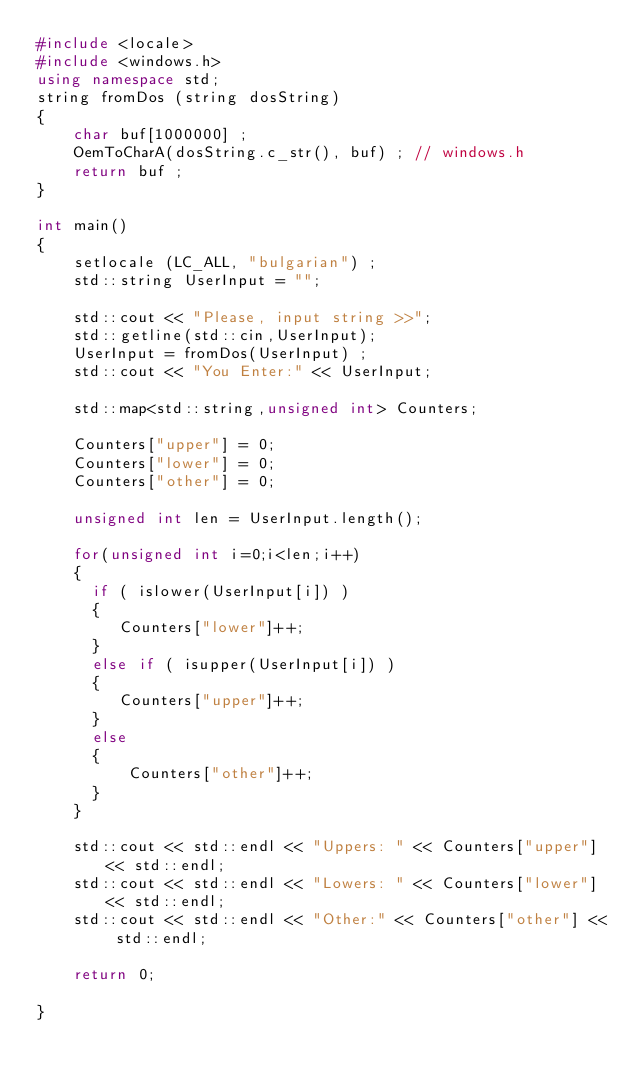<code> <loc_0><loc_0><loc_500><loc_500><_C++_>#include <locale>
#include <windows.h>
using namespace std;
string fromDos (string dosString)
{
	char buf[1000000] ;
	OemToCharA(dosString.c_str(), buf) ; // windows.h
	return buf ;
}

int main()
{
	setlocale (LC_ALL, "bulgarian") ;
    std::string UserInput = "";

    std::cout << "Please, input string >>";
    std::getline(std::cin,UserInput);
    UserInput = fromDos(UserInput) ;
    std::cout << "You Enter:" << UserInput;

    std::map<std::string,unsigned int> Counters;

    Counters["upper"] = 0;
    Counters["lower"] = 0;
    Counters["other"] = 0;

    unsigned int len = UserInput.length();

    for(unsigned int i=0;i<len;i++)
    {
      if ( islower(UserInput[i]) )
      {
         Counters["lower"]++;
      }
      else if ( isupper(UserInput[i]) )
      {
         Counters["upper"]++;
      }
      else
      {
          Counters["other"]++;
      }
    }

    std::cout << std::endl << "Uppers: " << Counters["upper"] << std::endl;
    std::cout << std::endl << "Lowers: " << Counters["lower"] << std::endl;
    std::cout << std::endl << "Other:" << Counters["other"] << std::endl;

    return 0;

}

</code> 